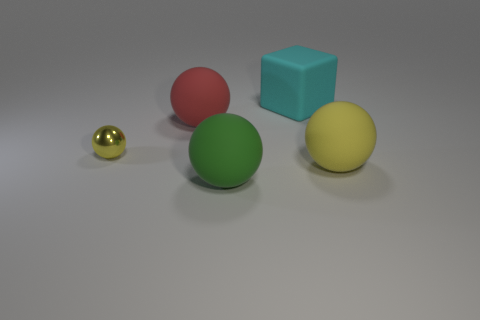Subtract all metal balls. How many balls are left? 3 Add 5 yellow blocks. How many objects exist? 10 Subtract all green balls. How many balls are left? 3 Add 3 small metallic balls. How many small metallic balls are left? 4 Add 1 spheres. How many spheres exist? 5 Subtract 0 green blocks. How many objects are left? 5 Subtract all balls. How many objects are left? 1 Subtract 1 cubes. How many cubes are left? 0 Subtract all brown cubes. Subtract all red balls. How many cubes are left? 1 Subtract all green cubes. How many green balls are left? 1 